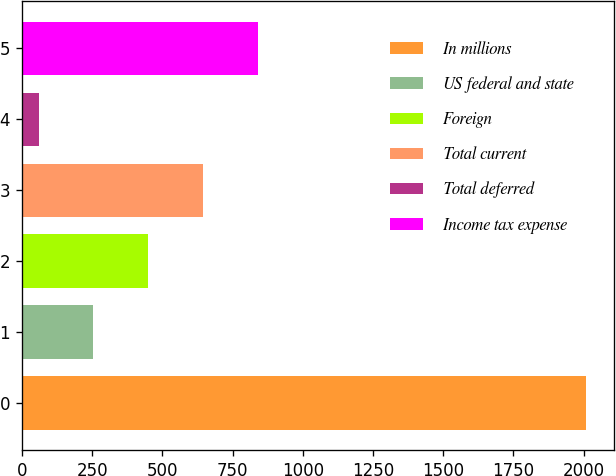Convert chart to OTSL. <chart><loc_0><loc_0><loc_500><loc_500><bar_chart><fcel>In millions<fcel>US federal and state<fcel>Foreign<fcel>Total current<fcel>Total deferred<fcel>Income tax expense<nl><fcel>2007<fcel>254.7<fcel>449.4<fcel>644.1<fcel>60<fcel>838.8<nl></chart> 